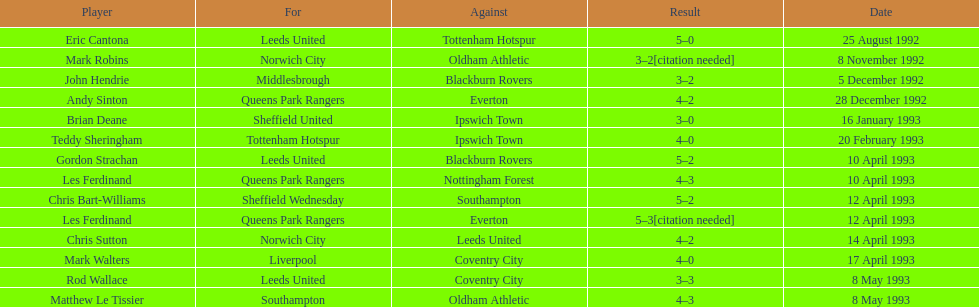Which competitor had a similar result to mark robins? John Hendrie. 